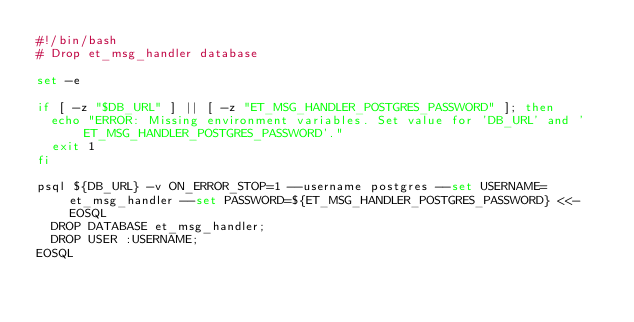<code> <loc_0><loc_0><loc_500><loc_500><_Bash_>#!/bin/bash
# Drop et_msg_handler database

set -e

if [ -z "$DB_URL" ] || [ -z "ET_MSG_HANDLER_POSTGRES_PASSWORD" ]; then
  echo "ERROR: Missing environment variables. Set value for 'DB_URL' and 'ET_MSG_HANDLER_POSTGRES_PASSWORD'."
  exit 1
fi

psql ${DB_URL} -v ON_ERROR_STOP=1 --username postgres --set USERNAME=et_msg_handler --set PASSWORD=${ET_MSG_HANDLER_POSTGRES_PASSWORD} <<-EOSQL
  DROP DATABASE et_msg_handler;
  DROP USER :USERNAME;
EOSQL
</code> 